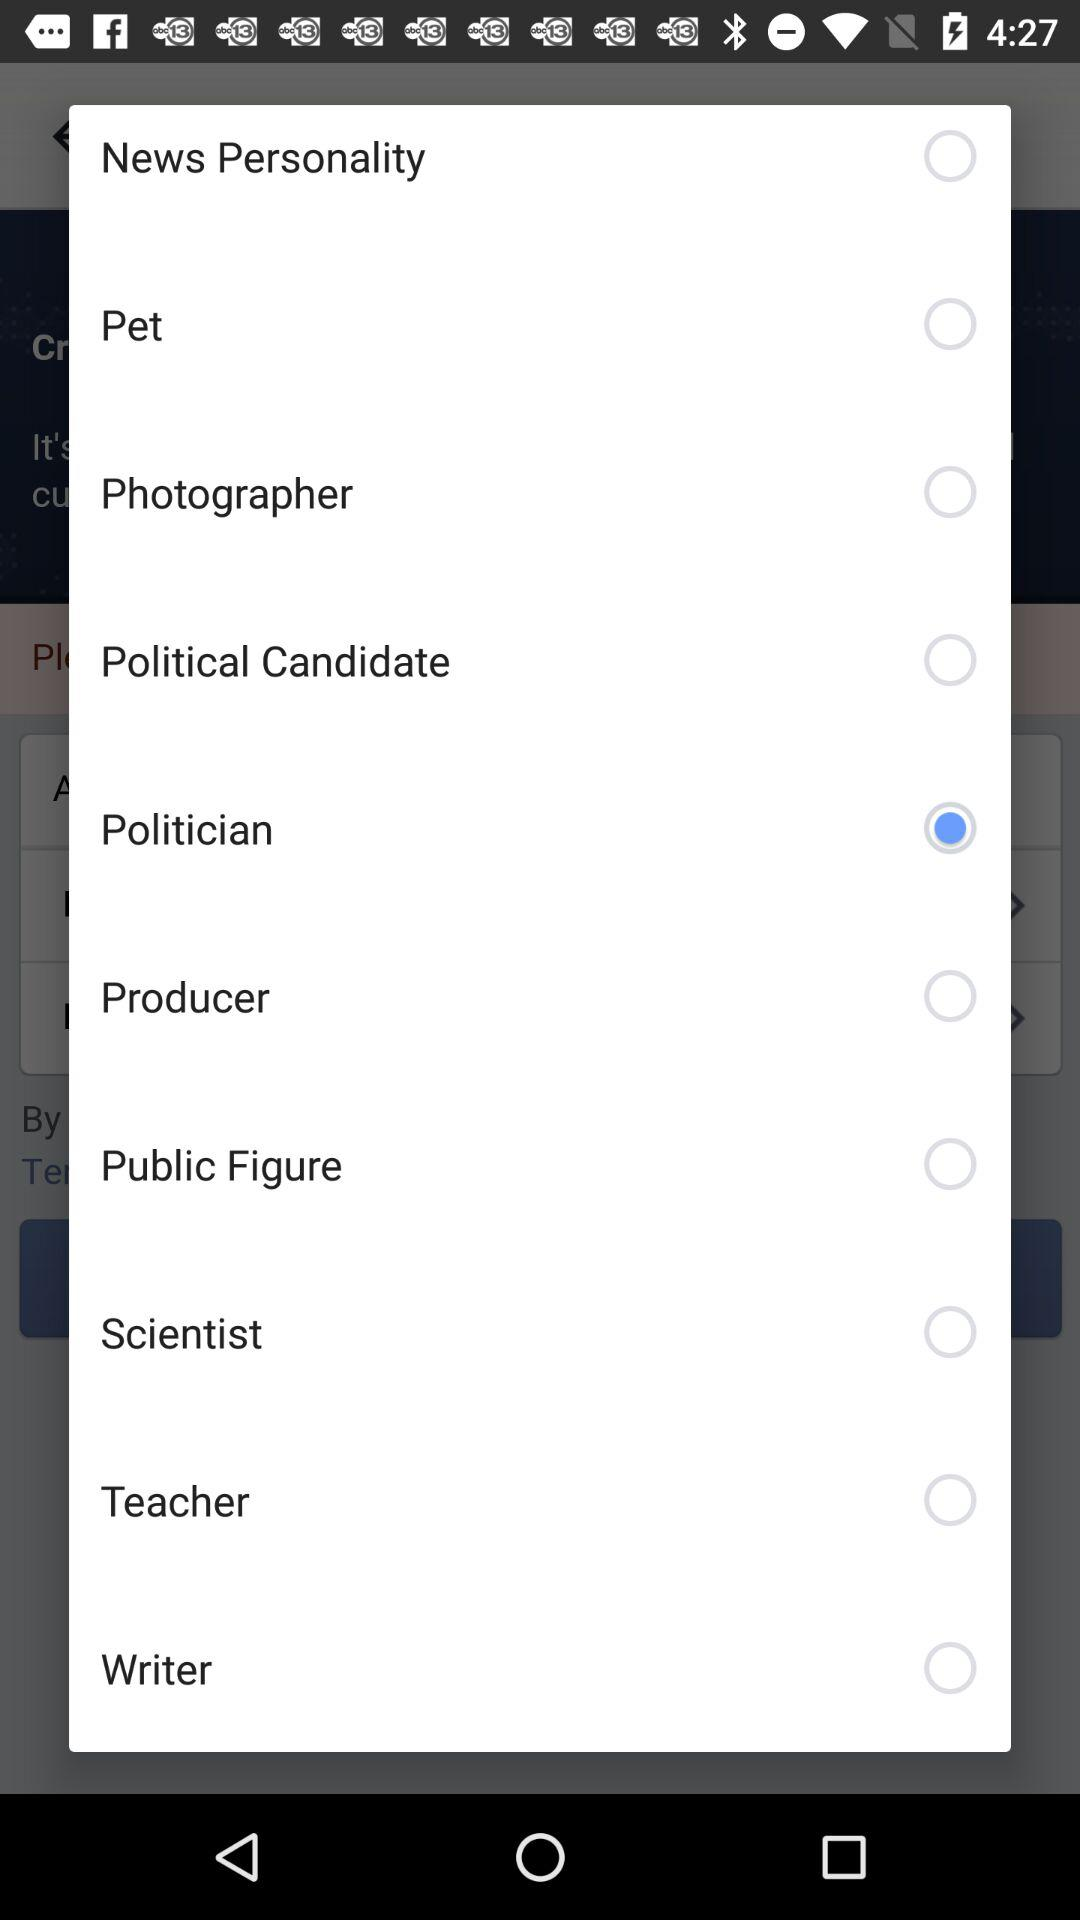Which category person is selected? The selected category is "Politician". 